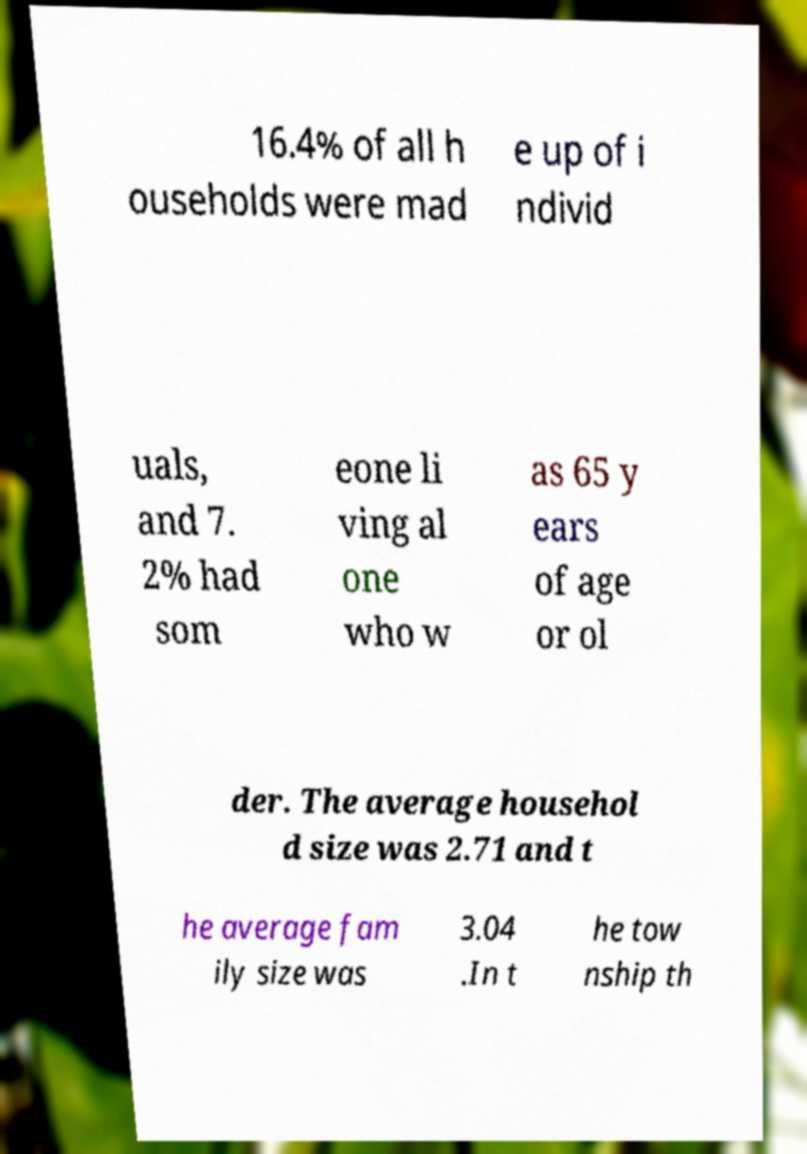Please read and relay the text visible in this image. What does it say? 16.4% of all h ouseholds were mad e up of i ndivid uals, and 7. 2% had som eone li ving al one who w as 65 y ears of age or ol der. The average househol d size was 2.71 and t he average fam ily size was 3.04 .In t he tow nship th 